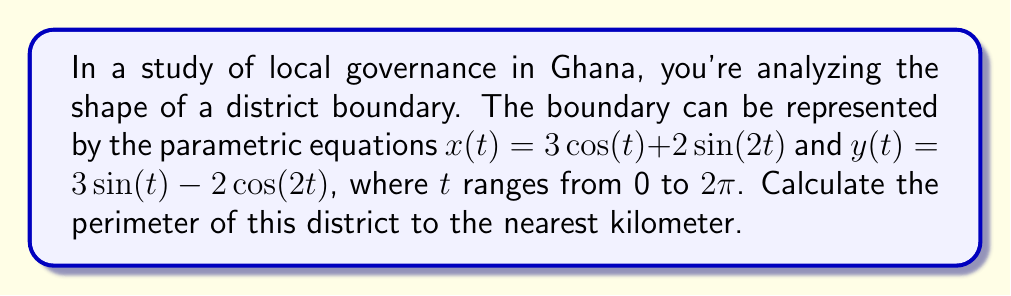Could you help me with this problem? To calculate the perimeter using parametric equations, we need to use the arc length formula:

$$L = \int_a^b \sqrt{\left(\frac{dx}{dt}\right)^2 + \left(\frac{dy}{dt}\right)^2} dt$$

Step 1: Find $\frac{dx}{dt}$ and $\frac{dy}{dt}$
$\frac{dx}{dt} = -3\sin(t) + 4\cos(2t)$
$\frac{dy}{dt} = 3\cos(t) + 4\sin(2t)$

Step 2: Square both derivatives
$\left(\frac{dx}{dt}\right)^2 = 9\sin^2(t) + 32\cos(2t)\sin(t) + 16\cos^2(2t)$
$\left(\frac{dy}{dt}\right)^2 = 9\cos^2(t) + 24\sin(2t)\cos(t) + 16\sin^2(2t)$

Step 3: Add the squared derivatives
$$\left(\frac{dx}{dt}\right)^2 + \left(\frac{dy}{dt}\right)^2 = 9(\sin^2(t) + \cos^2(t)) + 32\cos(2t)\sin(t) + 24\sin(2t)\cos(t) + 16(\cos^2(2t) + \sin^2(2t))$$

Step 4: Simplify using trigonometric identities
$\sin^2(t) + \cos^2(t) = 1$
$\cos^2(2t) + \sin^2(2t) = 1$
$32\cos(2t)\sin(t) + 24\sin(2t)\cos(t) = 28\sin(3t)$ (using trigonometric addition formulas)

$$\left(\frac{dx}{dt}\right)^2 + \left(\frac{dy}{dt}\right)^2 = 9 + 16 + 28\sin(3t) = 25 + 28\sin(3t)$$

Step 5: Take the square root and integrate
$$L = \int_0^{2\pi} \sqrt{25 + 28\sin(3t)} dt$$

This integral cannot be solved analytically. We need to use numerical integration methods.

Step 6: Use a numerical integration method (e.g., Simpson's rule or a computer algebra system) to evaluate the integral.

The result of this numerical integration is approximately 20.78 km.

Step 7: Round to the nearest kilometer
20.78 km rounds to 21 km.
Answer: 21 km 